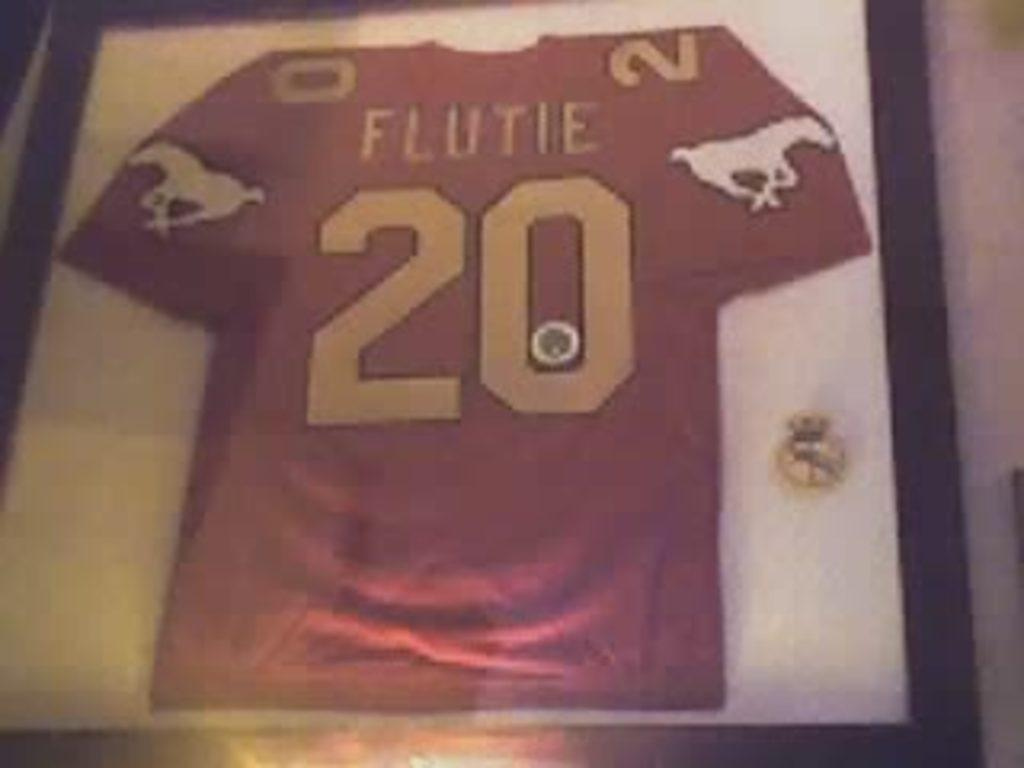Provide a one-sentence caption for the provided image. number twenty jersey for a player named flutie. 